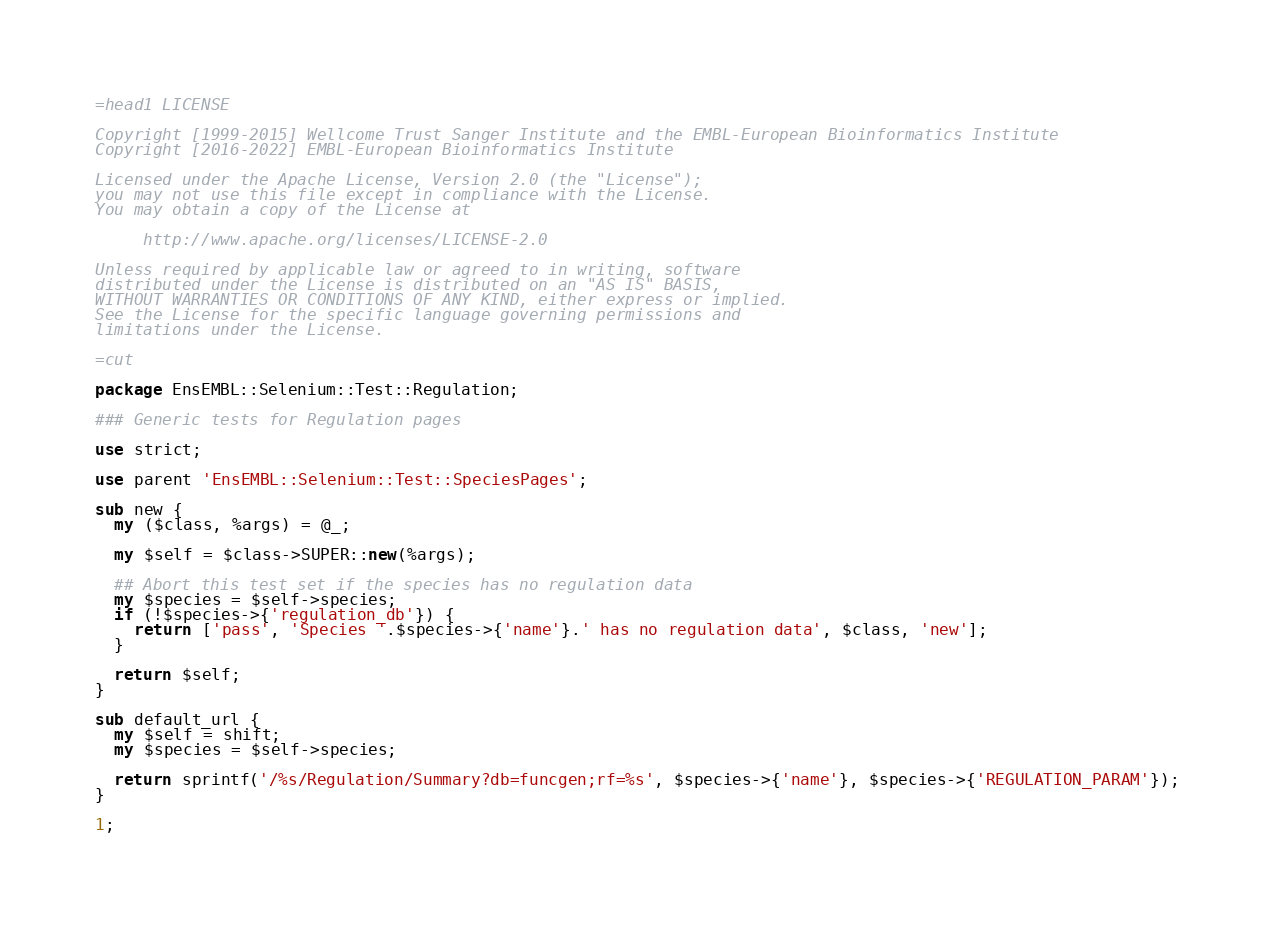<code> <loc_0><loc_0><loc_500><loc_500><_Perl_>=head1 LICENSE

Copyright [1999-2015] Wellcome Trust Sanger Institute and the EMBL-European Bioinformatics Institute
Copyright [2016-2022] EMBL-European Bioinformatics Institute

Licensed under the Apache License, Version 2.0 (the "License");
you may not use this file except in compliance with the License.
You may obtain a copy of the License at

     http://www.apache.org/licenses/LICENSE-2.0

Unless required by applicable law or agreed to in writing, software
distributed under the License is distributed on an "AS IS" BASIS,
WITHOUT WARRANTIES OR CONDITIONS OF ANY KIND, either express or implied.
See the License for the specific language governing permissions and
limitations under the License.

=cut

package EnsEMBL::Selenium::Test::Regulation;

### Generic tests for Regulation pages

use strict;

use parent 'EnsEMBL::Selenium::Test::SpeciesPages';

sub new {
  my ($class, %args) = @_;

  my $self = $class->SUPER::new(%args);

  ## Abort this test set if the species has no regulation data
  my $species = $self->species;
  if (!$species->{'regulation_db'}) {
    return ['pass', 'Species '.$species->{'name'}.' has no regulation data', $class, 'new'];
  }

  return $self;
}

sub default_url {
  my $self = shift;
  my $species = $self->species;

  return sprintf('/%s/Regulation/Summary?db=funcgen;rf=%s', $species->{'name'}, $species->{'REGULATION_PARAM'});
}

1;
</code> 